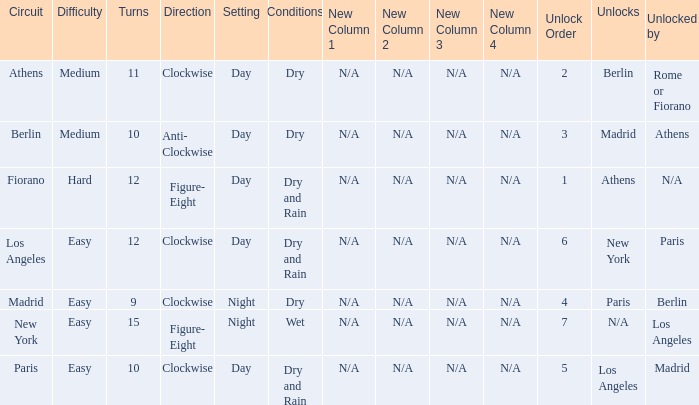Would you be able to parse every entry in this table? {'header': ['Circuit', 'Difficulty', 'Turns', 'Direction', 'Setting', 'Conditions', 'New Column 1', 'New Column 2', 'New Column 3', 'New Column 4', 'Unlock Order', 'Unlocks', 'Unlocked by'], 'rows': [['Athens', 'Medium', '11', 'Clockwise', 'Day', 'Dry', 'N/A', 'N/A', 'N/A', 'N/A', '2', 'Berlin', 'Rome or Fiorano'], ['Berlin', 'Medium', '10', 'Anti- Clockwise', 'Day', 'Dry', 'N/A', 'N/A', 'N/A', 'N/A', '3', 'Madrid', 'Athens'], ['Fiorano', 'Hard', '12', 'Figure- Eight', 'Day', 'Dry and Rain', 'N/A', 'N/A', 'N/A', 'N/A', '1', 'Athens', 'N/A'], ['Los Angeles', 'Easy', '12', 'Clockwise', 'Day', 'Dry and Rain', 'N/A', 'N/A', 'N/A', 'N/A', '6', 'New York', 'Paris'], ['Madrid', 'Easy', '9', 'Clockwise', 'Night', 'Dry', 'N/A', 'N/A', 'N/A', 'N/A', '4', 'Paris', 'Berlin'], ['New York', 'Easy', '15', 'Figure- Eight', 'Night', 'Wet', 'N/A', 'N/A', 'N/A', 'N/A', '7', 'N/A', 'Los Angeles'], ['Paris', 'Easy', '10', 'Clockwise', 'Day', 'Dry and Rain', 'N/A', 'N/A', 'N/A', 'N/A', '5', 'Los Angeles', 'Madrid']]} What is the difficulty of the athens circuit? Medium. 